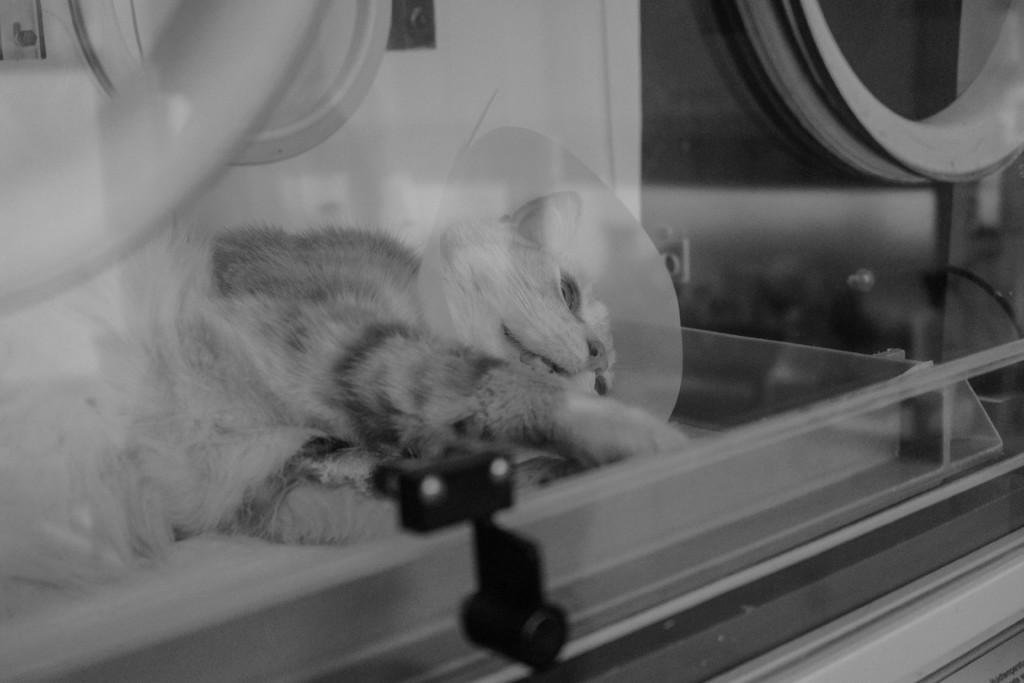What type of animal is in the picture? There is a cat in the picture. What position is the cat in? The cat is lying under the glass. Where is the glass located in relation to the wall? The glass is near the wall. What type of bell can be heard ringing in the image? There is no bell present in the image, and therefore no sound can be heard. 